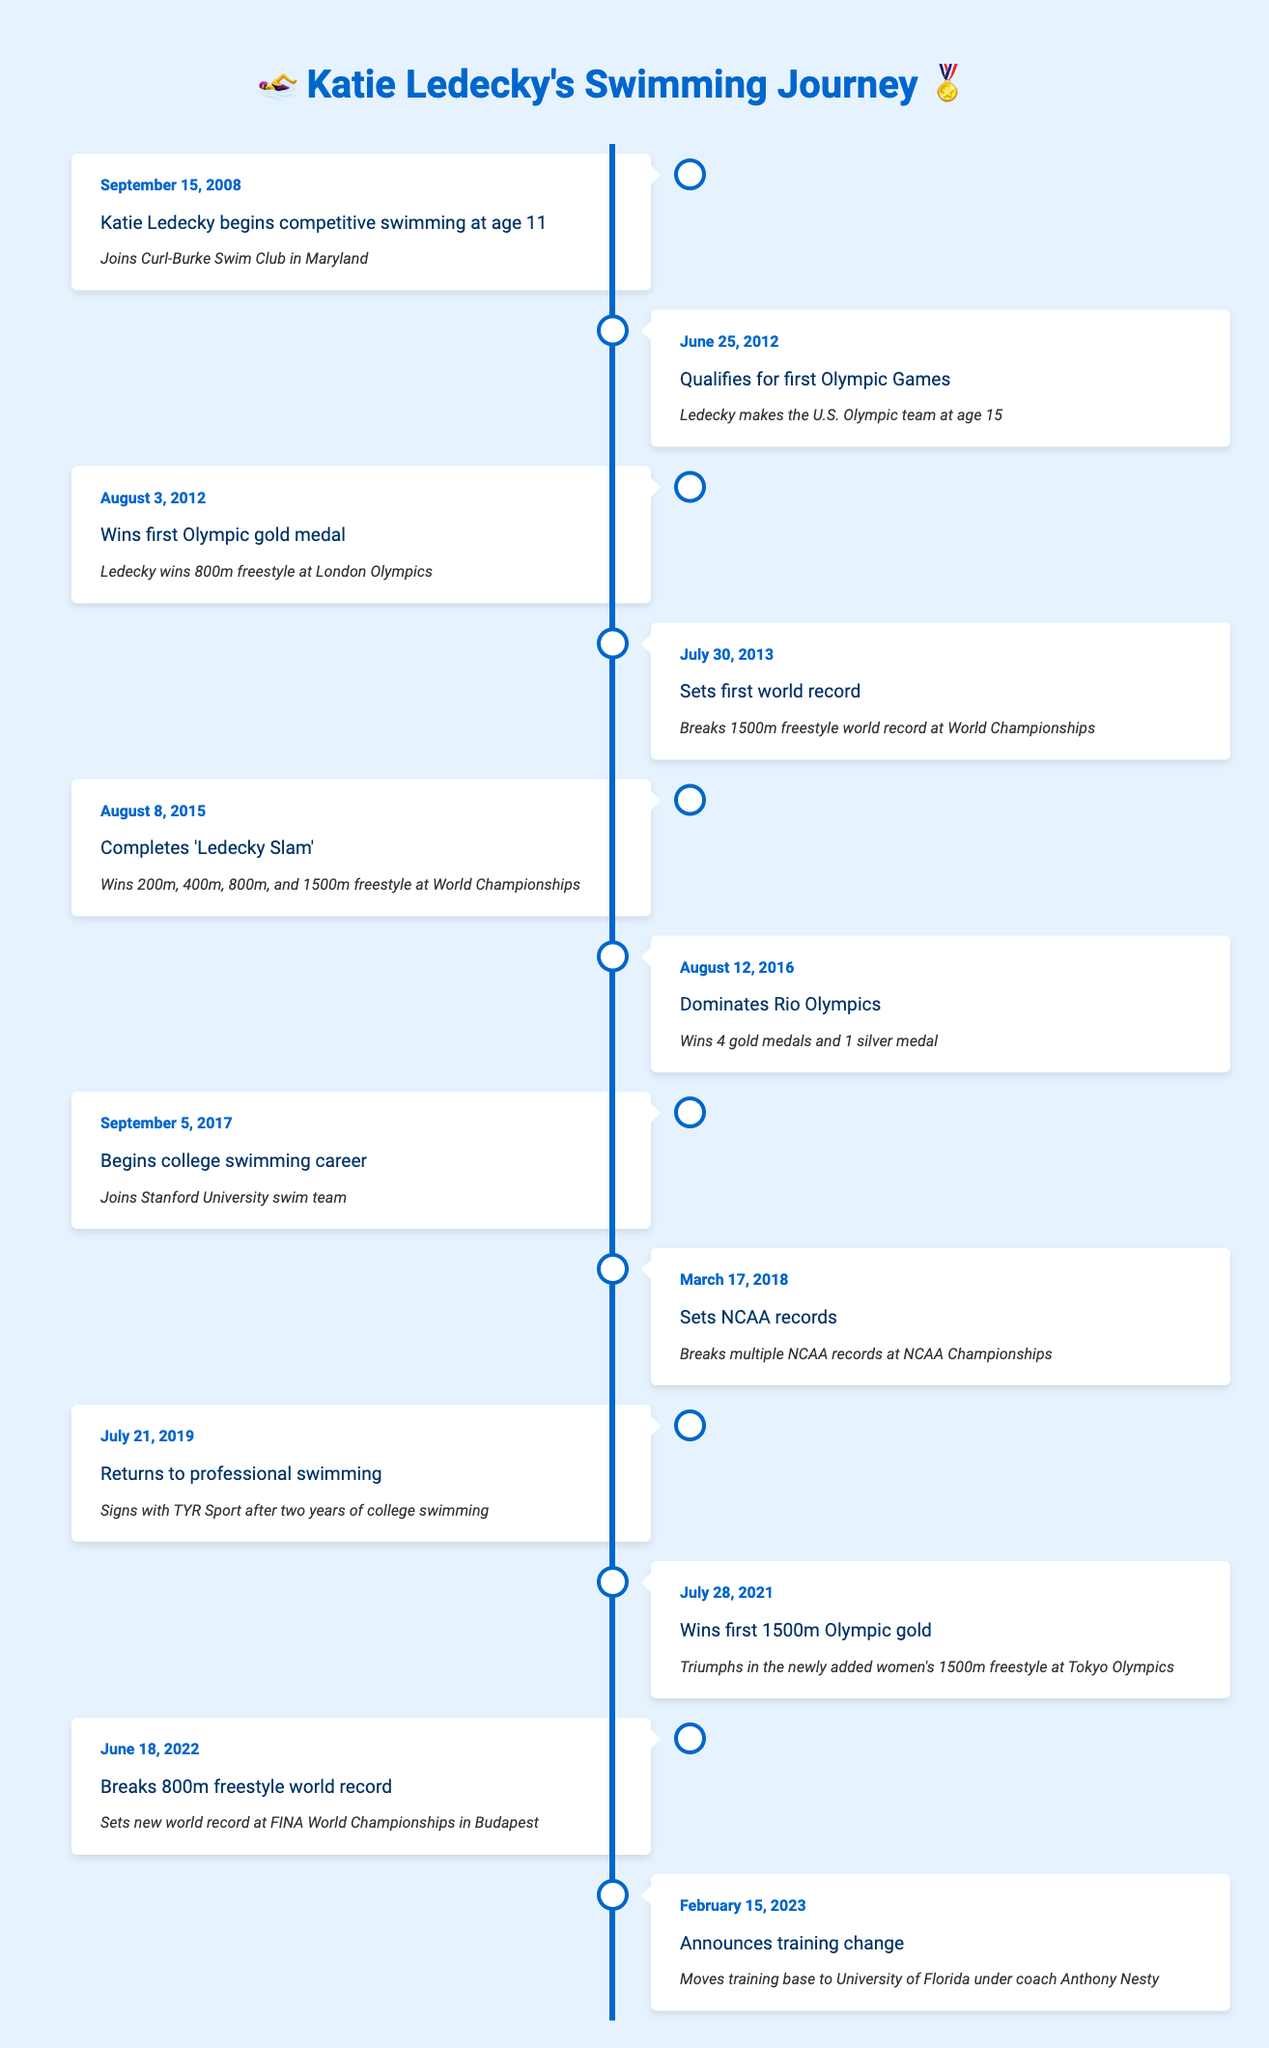What age did Katie Ledecky start competitive swimming? According to the timeline, Katie Ledecky began competitive swimming at the age of 11, as noted in the event from September 15, 2008.
Answer: 11 How many gold medals did Katie Ledecky win at the Rio Olympics? The timeline states that she won 4 gold medals at the Rio Olympics, described in the event on August 12, 2016.
Answer: 4 Did Katie Ledecky break any records during her college swimming career? Yes, she broke multiple NCAA records as stated in the event from March 17, 2018.
Answer: Yes What is the time gap between Ledecky's first Olympic gold medal and her first world record? Ledecky won her first Olympic gold medal on August 3, 2012, and set her first world record on July 30, 2013. The time gap is approximately 11 months (from August 2012 to July 2013).
Answer: 11 months How many events did Ledecky win to complete the 'Ledecky Slam'? The timeline lists that she won 200m, 400m, 800m, and 1500m freestyle events at the World Championships, amounting to 4 events.
Answer: 4 events What major change did Katie Ledecky announce in February 2023? The timeline indicates that she announced a training change, moving her training base to the University of Florida under coach Anthony Nesty on February 15, 2023.
Answer: Training change What was the last event listed in the timeline? The last event in the timeline is the announcement of a training change on February 15, 2023.
Answer: Training change How many total international competitions are mentioned in the timeline? The timeline has 7 distinct events related to international competitions (Olympics and World Championships) from different years.
Answer: 7 events What is the time span from Ledecky's first competition to her latest major event? The first competition mentioned is from September 15, 2008, and the latest event is from February 15, 2023. Calculating the years gives a time span of about 14 years and 5 months.
Answer: 14 years and 5 months 